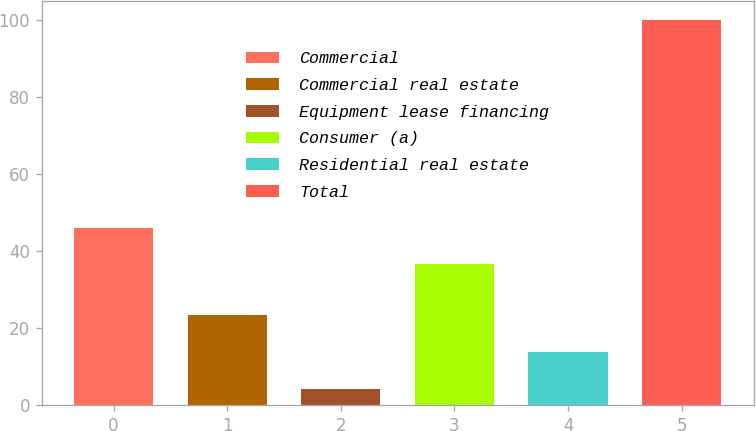Convert chart. <chart><loc_0><loc_0><loc_500><loc_500><bar_chart><fcel>Commercial<fcel>Commercial real estate<fcel>Equipment lease financing<fcel>Consumer (a)<fcel>Residential real estate<fcel>Total<nl><fcel>46.18<fcel>23.36<fcel>4.2<fcel>36.6<fcel>13.78<fcel>100<nl></chart> 